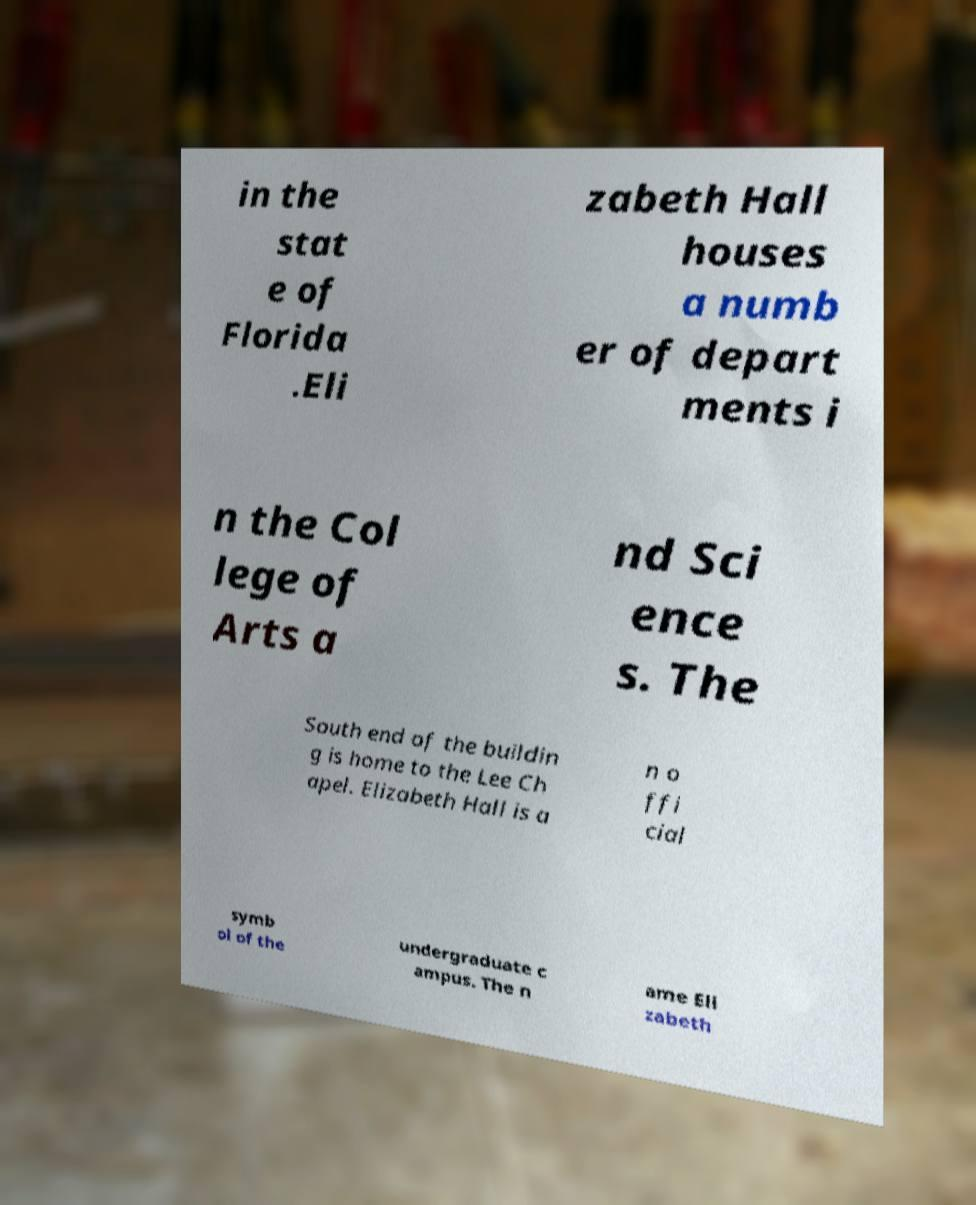There's text embedded in this image that I need extracted. Can you transcribe it verbatim? in the stat e of Florida .Eli zabeth Hall houses a numb er of depart ments i n the Col lege of Arts a nd Sci ence s. The South end of the buildin g is home to the Lee Ch apel. Elizabeth Hall is a n o ffi cial symb ol of the undergraduate c ampus. The n ame Eli zabeth 